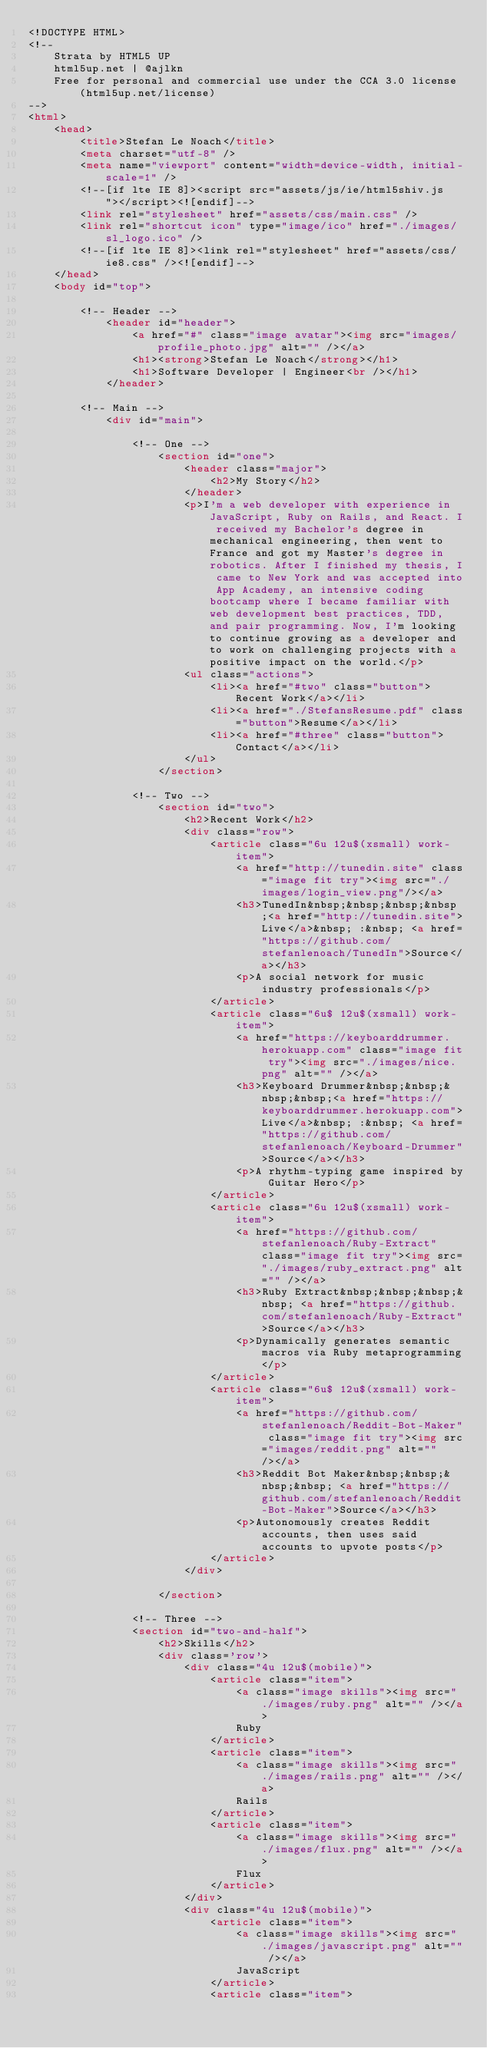<code> <loc_0><loc_0><loc_500><loc_500><_HTML_><!DOCTYPE HTML>
<!--
	Strata by HTML5 UP
	html5up.net | @ajlkn
	Free for personal and commercial use under the CCA 3.0 license (html5up.net/license)
-->
<html>
	<head>
		<title>Stefan Le Noach</title>
		<meta charset="utf-8" />
		<meta name="viewport" content="width=device-width, initial-scale=1" />
		<!--[if lte IE 8]><script src="assets/js/ie/html5shiv.js"></script><![endif]-->
		<link rel="stylesheet" href="assets/css/main.css" />
		<link rel="shortcut icon" type="image/ico" href="./images/sl_logo.ico" />
		<!--[if lte IE 8]><link rel="stylesheet" href="assets/css/ie8.css" /><![endif]-->
	</head>
	<body id="top">

		<!-- Header -->
			<header id="header">
				<a href="#" class="image avatar"><img src="images/profile_photo.jpg" alt="" /></a>
				<h1><strong>Stefan Le Noach</strong></h1>
				<h1>Software Developer | Engineer<br /></h1>
			</header>

		<!-- Main -->
			<div id="main">

				<!-- One -->
					<section id="one">
						<header class="major">
							<h2>My Story</h2>
						</header>
						<p>I'm a web developer with experience in JavaScript, Ruby on Rails, and React. I received my Bachelor's degree in mechanical engineering, then went to France and got my Master's degree in robotics. After I finished my thesis, I came to New York and was accepted into App Academy, an intensive coding bootcamp where I became familiar with web development best practices, TDD, and pair programming. Now, I'm looking to continue growing as a developer and to work on challenging projects with a positive impact on the world.</p>
						<ul class="actions">
							<li><a href="#two" class="button">Recent Work</a></li>
							<li><a href="./StefansResume.pdf" class="button">Resume</a></li>
							<li><a href="#three" class="button">Contact</a></li>
						</ul>
					</section>

				<!-- Two -->
					<section id="two">
						<h2>Recent Work</h2>
						<div class="row">
							<article class="6u 12u$(xsmall) work-item">
								<a href="http://tunedin.site" class="image fit try"><img src="./images/login_view.png"/></a>
								<h3>TunedIn&nbsp;&nbsp;&nbsp;&nbsp;<a href="http://tunedin.site">Live</a>&nbsp; :&nbsp; <a href="https://github.com/stefanlenoach/TunedIn">Source</a></h3>
								<p>A social network for music industry professionals</p>
							</article>
							<article class="6u$ 12u$(xsmall) work-item">
								<a href="https://keyboarddrummer.herokuapp.com" class="image fit try"><img src="./images/nice.png" alt="" /></a>
								<h3>Keyboard Drummer&nbsp;&nbsp;&nbsp;&nbsp;<a href="https://keyboarddrummer.herokuapp.com">Live</a>&nbsp; :&nbsp; <a href="https://github.com/stefanlenoach/Keyboard-Drummer">Source</a></h3>
								<p>A rhythm-typing game inspired by Guitar Hero</p>
							</article>
							<article class="6u 12u$(xsmall) work-item">
								<a href="https://github.com/stefanlenoach/Ruby-Extract" class="image fit try"><img src="./images/ruby_extract.png" alt="" /></a>
								<h3>Ruby Extract&nbsp;&nbsp;&nbsp;&nbsp; <a href="https://github.com/stefanlenoach/Ruby-Extract">Source</a></h3>
								<p>Dynamically generates semantic macros via Ruby metaprogramming</p>
							</article>
							<article class="6u$ 12u$(xsmall) work-item">
								<a href="https://github.com/stefanlenoach/Reddit-Bot-Maker" class="image fit try"><img src="images/reddit.png" alt="" /></a>
								<h3>Reddit Bot Maker&nbsp;&nbsp;&nbsp;&nbsp; <a href="https://github.com/stefanlenoach/Reddit-Bot-Maker">Source</a></h3>
								<p>Autonomously creates Reddit accounts, then uses said accounts to upvote posts</p>
							</article>
						</div>

					</section>

				<!-- Three -->
				<section id="two-and-half">
					<h2>Skills</h2>
					<div class='row'>
						<div class="4u 12u$(mobile)">
							<article class="item">
								<a class="image skills"><img src="./images/ruby.png" alt="" /></a>
								Ruby
							</article>
							<article class="item">
								<a class="image skills"><img src="./images/rails.png" alt="" /></a>
								Rails
							</article>
							<article class="item">
								<a class="image skills"><img src="./images/flux.png" alt="" /></a>
								Flux
							</article>
						</div>
						<div class="4u 12u$(mobile)">
							<article class="item">
								<a class="image skills"><img src="./images/javascript.png" alt="" /></a>
								JavaScript
							</article>
							<article class="item"></code> 